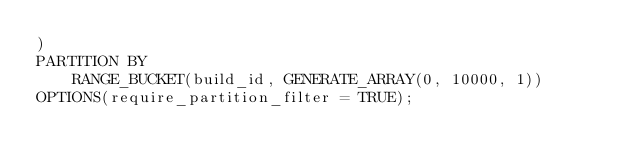<code> <loc_0><loc_0><loc_500><loc_500><_SQL_>) 
PARTITION BY 
    RANGE_BUCKET(build_id, GENERATE_ARRAY(0, 10000, 1)) 
OPTIONS(require_partition_filter = TRUE);</code> 